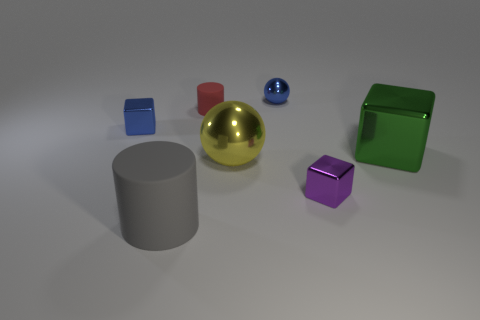There is a cube behind the green metal cube; is its color the same as the small sphere that is to the left of the green metal thing?
Offer a terse response. Yes. The other cylinder that is made of the same material as the small cylinder is what size?
Provide a succinct answer. Large. There is a small cube that is right of the rubber cylinder in front of the metallic cube left of the tiny rubber thing; what is its material?
Offer a terse response. Metal. What number of cubes are tiny red objects or small objects?
Offer a terse response. 2. What number of small metallic things are in front of the matte cylinder that is behind the big metallic thing to the right of the tiny purple block?
Provide a short and direct response. 2. Is the shape of the small purple metal object the same as the green thing?
Keep it short and to the point. Yes. Does the small object that is in front of the green thing have the same material as the large thing that is to the left of the tiny red cylinder?
Your answer should be compact. No. What number of things are tiny shiny objects right of the yellow thing or tiny shiny blocks behind the yellow metal ball?
Your response must be concise. 3. How many shiny balls are there?
Your answer should be compact. 2. Is there another thing that has the same size as the yellow shiny thing?
Offer a very short reply. Yes. 